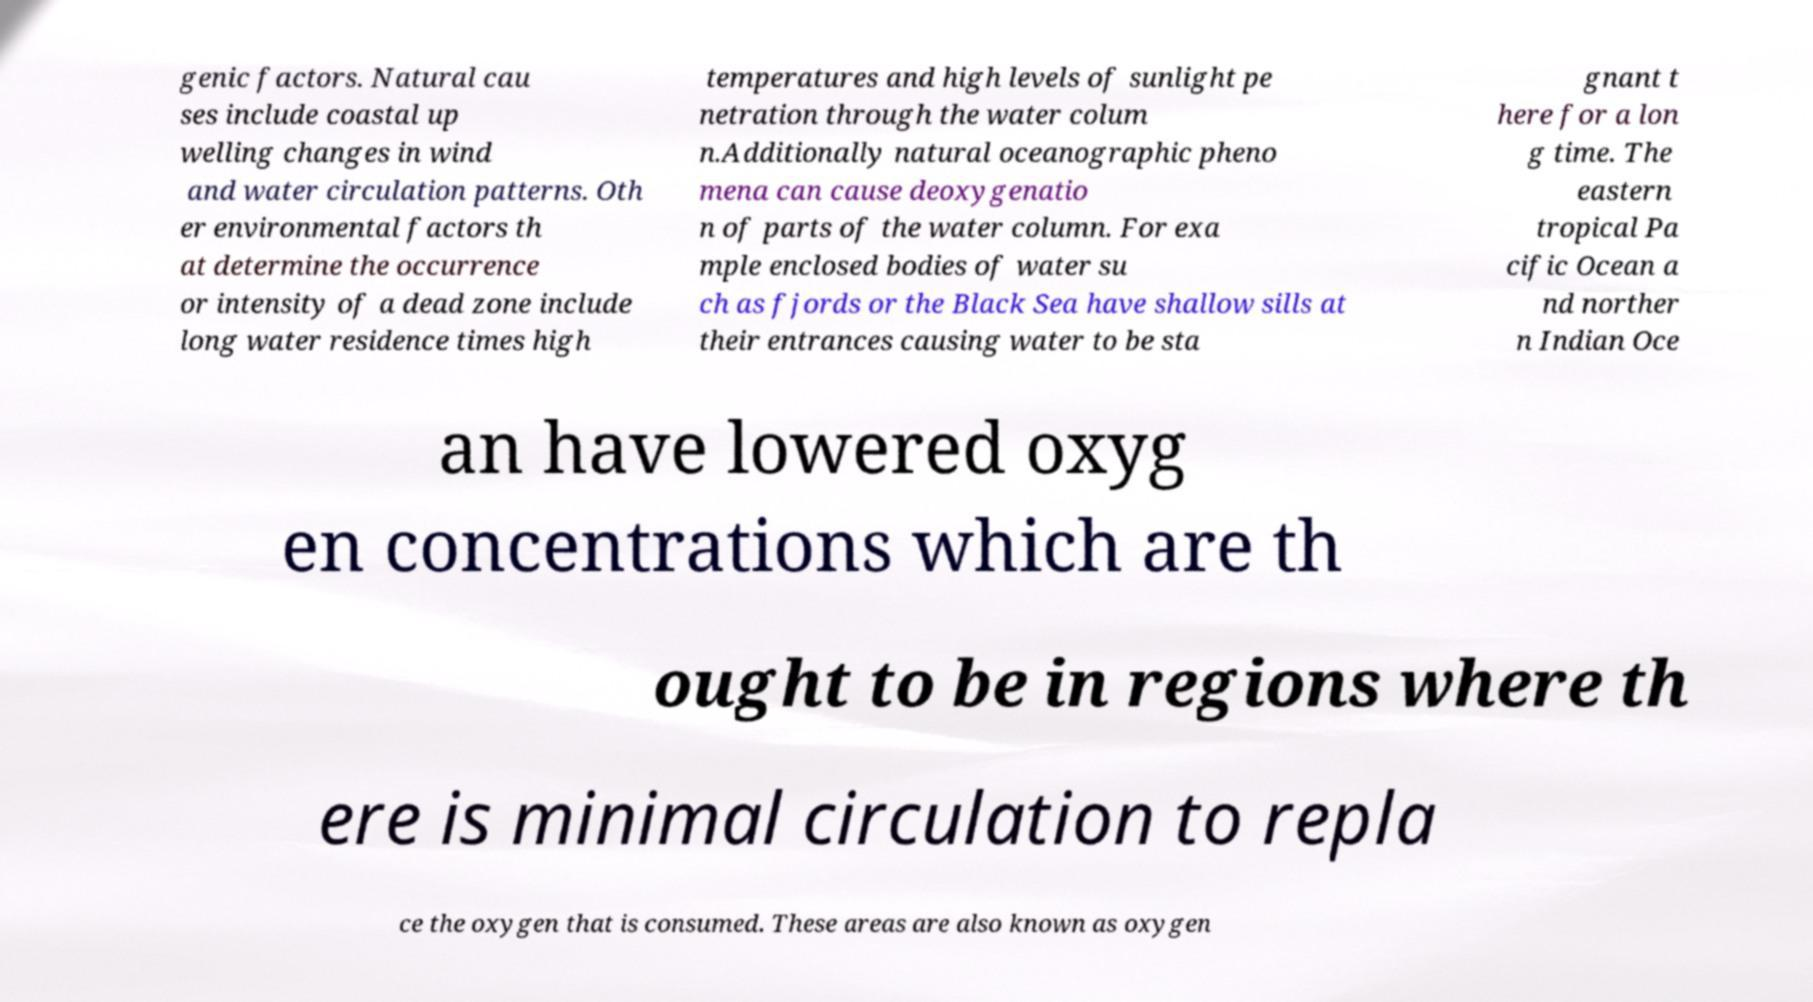Can you accurately transcribe the text from the provided image for me? genic factors. Natural cau ses include coastal up welling changes in wind and water circulation patterns. Oth er environmental factors th at determine the occurrence or intensity of a dead zone include long water residence times high temperatures and high levels of sunlight pe netration through the water colum n.Additionally natural oceanographic pheno mena can cause deoxygenatio n of parts of the water column. For exa mple enclosed bodies of water su ch as fjords or the Black Sea have shallow sills at their entrances causing water to be sta gnant t here for a lon g time. The eastern tropical Pa cific Ocean a nd norther n Indian Oce an have lowered oxyg en concentrations which are th ought to be in regions where th ere is minimal circulation to repla ce the oxygen that is consumed. These areas are also known as oxygen 